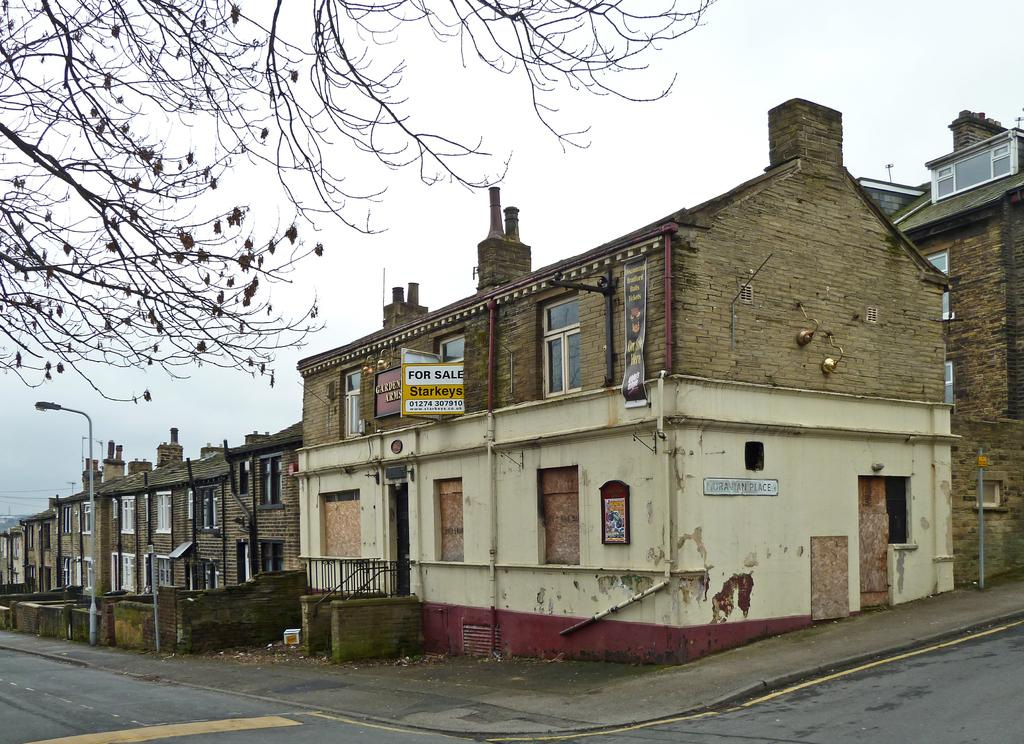What type of structures are present in the image? There are buildings in the image. What is located in front of the buildings? There is a street light in front of the buildings. What type of vegetation can be seen in the image? There are trees in the image. What is the main pathway visible in the image? There is a road in the image. What can be seen in the background of the image? The sky is visible in the background of the image. How does the argument between the trees resolve itself in the image? There is no argument between the trees in the image, as trees do not engage in arguments. What type of sorting algorithm is used by the buildings in the image? There is no sorting algorithm used by the buildings in the image, as buildings do not use sorting algorithms. 